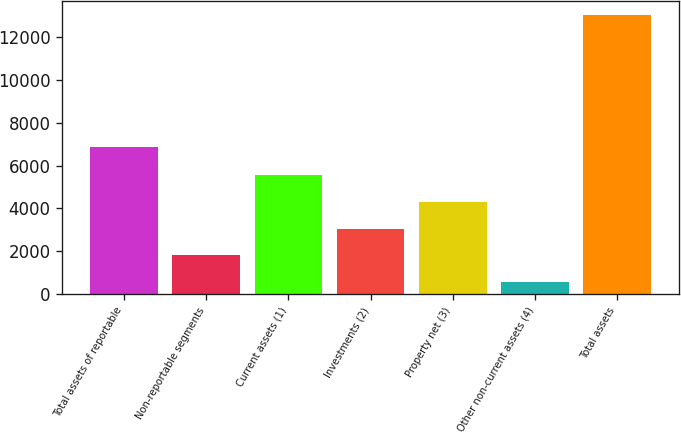Convert chart. <chart><loc_0><loc_0><loc_500><loc_500><bar_chart><fcel>Total assets of reportable<fcel>Non-reportable segments<fcel>Current assets (1)<fcel>Investments (2)<fcel>Property net (3)<fcel>Other non-current assets (4)<fcel>Total assets<nl><fcel>6892<fcel>1803.3<fcel>5557.2<fcel>3054.6<fcel>4305.9<fcel>552<fcel>13065<nl></chart> 